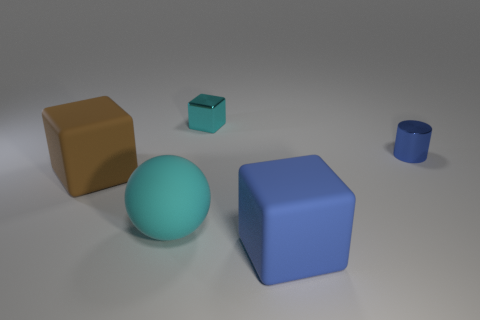Add 2 blue rubber things. How many objects exist? 7 Subtract all blocks. How many objects are left? 2 Subtract 0 blue spheres. How many objects are left? 5 Subtract all blue matte things. Subtract all cyan things. How many objects are left? 2 Add 1 large matte blocks. How many large matte blocks are left? 3 Add 3 yellow metallic balls. How many yellow metallic balls exist? 3 